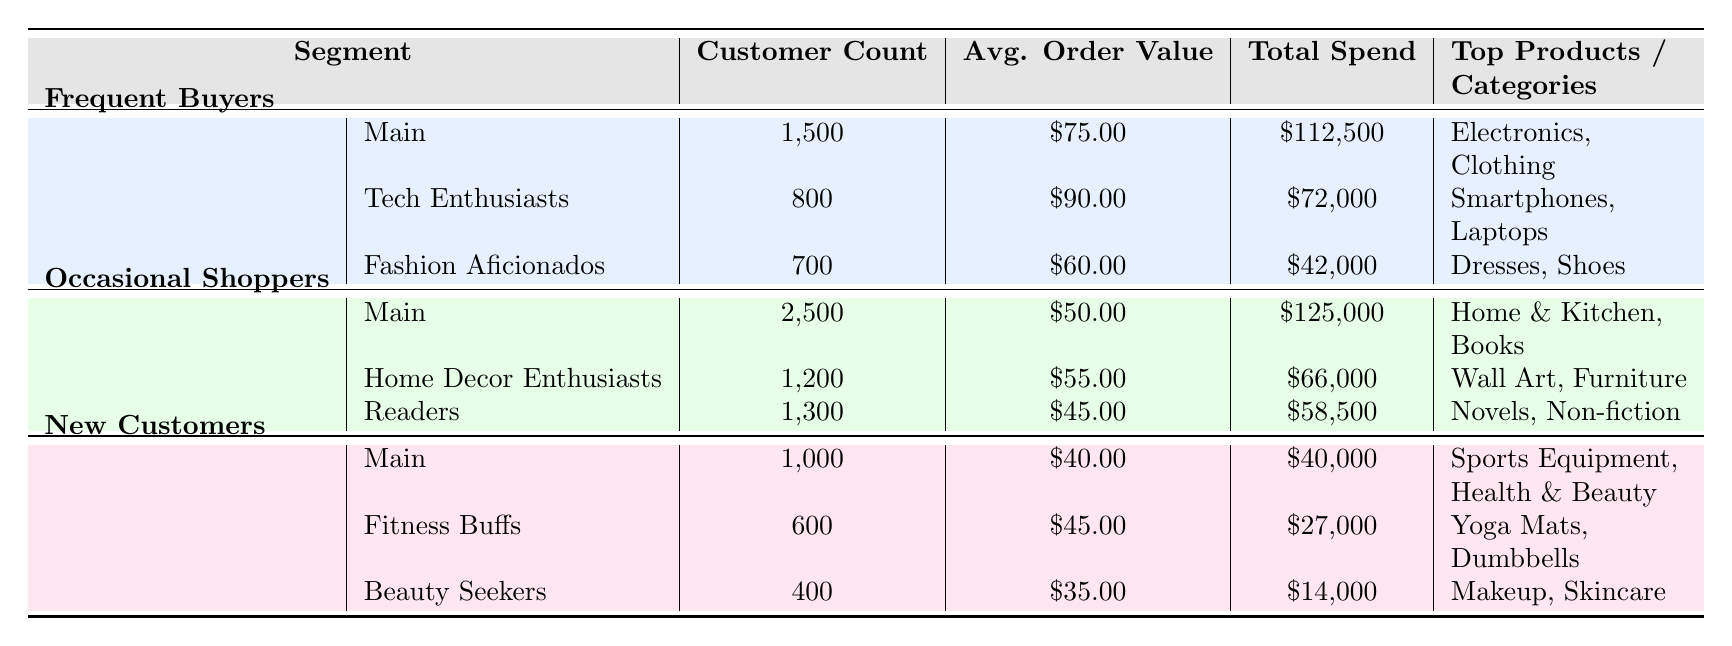What is the total customer count for the Frequent Buyers segment? The customer count for the Frequent Buyers segment is directly listed in the table under the "Customer Count" column for that segment, which is 1,500.
Answer: 1,500 What is the average order value for the Home Decor Enthusiasts sub-segment? The average order value for Home Decor Enthusiasts is shown in the "Avg. Order Value" column, which states it is 55.00.
Answer: 55.00 Which customer segment has the highest total spend? The total spend for each segment is provided in the "Total Spend" column. Frequent Buyers have 112,500, Occasional Shoppers have 125,000, and New Customers have 40,000. Comparing these figures, Occasional Shoppers has the highest total spend.
Answer: Occasional Shoppers Is the average order value for Fashion Aficionados greater than 60.00? Referring to the "Avg. Order Value" for Fashion Aficionados, it is stated to be 60.00. Therefore, the statement that it is greater than 60.00 is false.
Answer: No Calculate the total customer count across all segments. The customer counts for each segment are 1,500 for Frequent Buyers, 2,500 for Occasional Shoppers, and 1,000 for New Customers. Summing these values gives: 1,500 + 2,500 + 1,000 = 5,000.
Answer: 5,000 What are the top products for the sub-segment Tech Enthusiasts? The top products for Tech Enthusiasts are listed in the "Top Products" column, which specifies Smartphones and Laptops.
Answer: Smartphones, Laptops Does the Average Order Value for New Customers exceed that of Occasional Shoppers? The Average Order Value for New Customers is 40.00, while for Occasional Shoppers it is 50.00. Since 40.00 is less than 50.00, the answer is false.
Answer: No What is the total spend for Fitness Buffs and Beauty Seekers combined? The total spend for Fitness Buffs is 27,000 and for Beauty Seekers is 14,000. Adding these amounts: 27,000 + 14,000 = 41,000 gives the combined total spend for both sub-segments.
Answer: 41,000 Which sub-segment has the lowest average order value? The average order values for the sub-segments are: Tech Enthusiasts at 90.00, Fashion Aficionados at 60.00, Home Decor Enthusiasts at 55.00, Readers at 45.00, Fitness Buffs at 45.00, and Beauty Seekers at 35.00. Comparing these values, Beauty Seekers has the lowest average order value of 35.00.
Answer: Beauty Seekers 